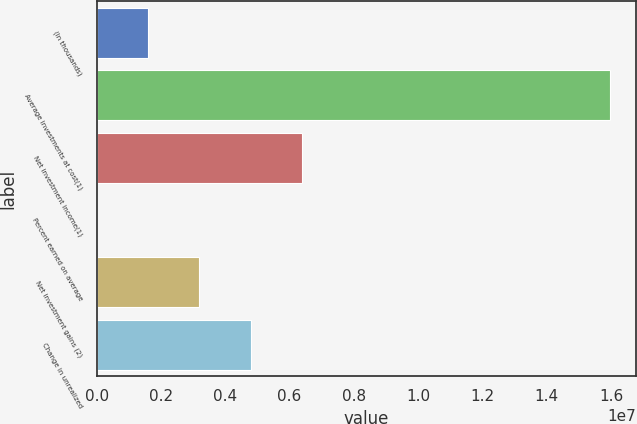<chart> <loc_0><loc_0><loc_500><loc_500><bar_chart><fcel>(In thousands)<fcel>Average investments at cost(1)<fcel>Net investment income(1)<fcel>Percent earned on average<fcel>Net investment gains (2)<fcel>Change in unrealized<nl><fcel>1.5971e+06<fcel>1.59709e+07<fcel>6.38837e+06<fcel>3.2<fcel>3.19419e+06<fcel>4.79128e+06<nl></chart> 